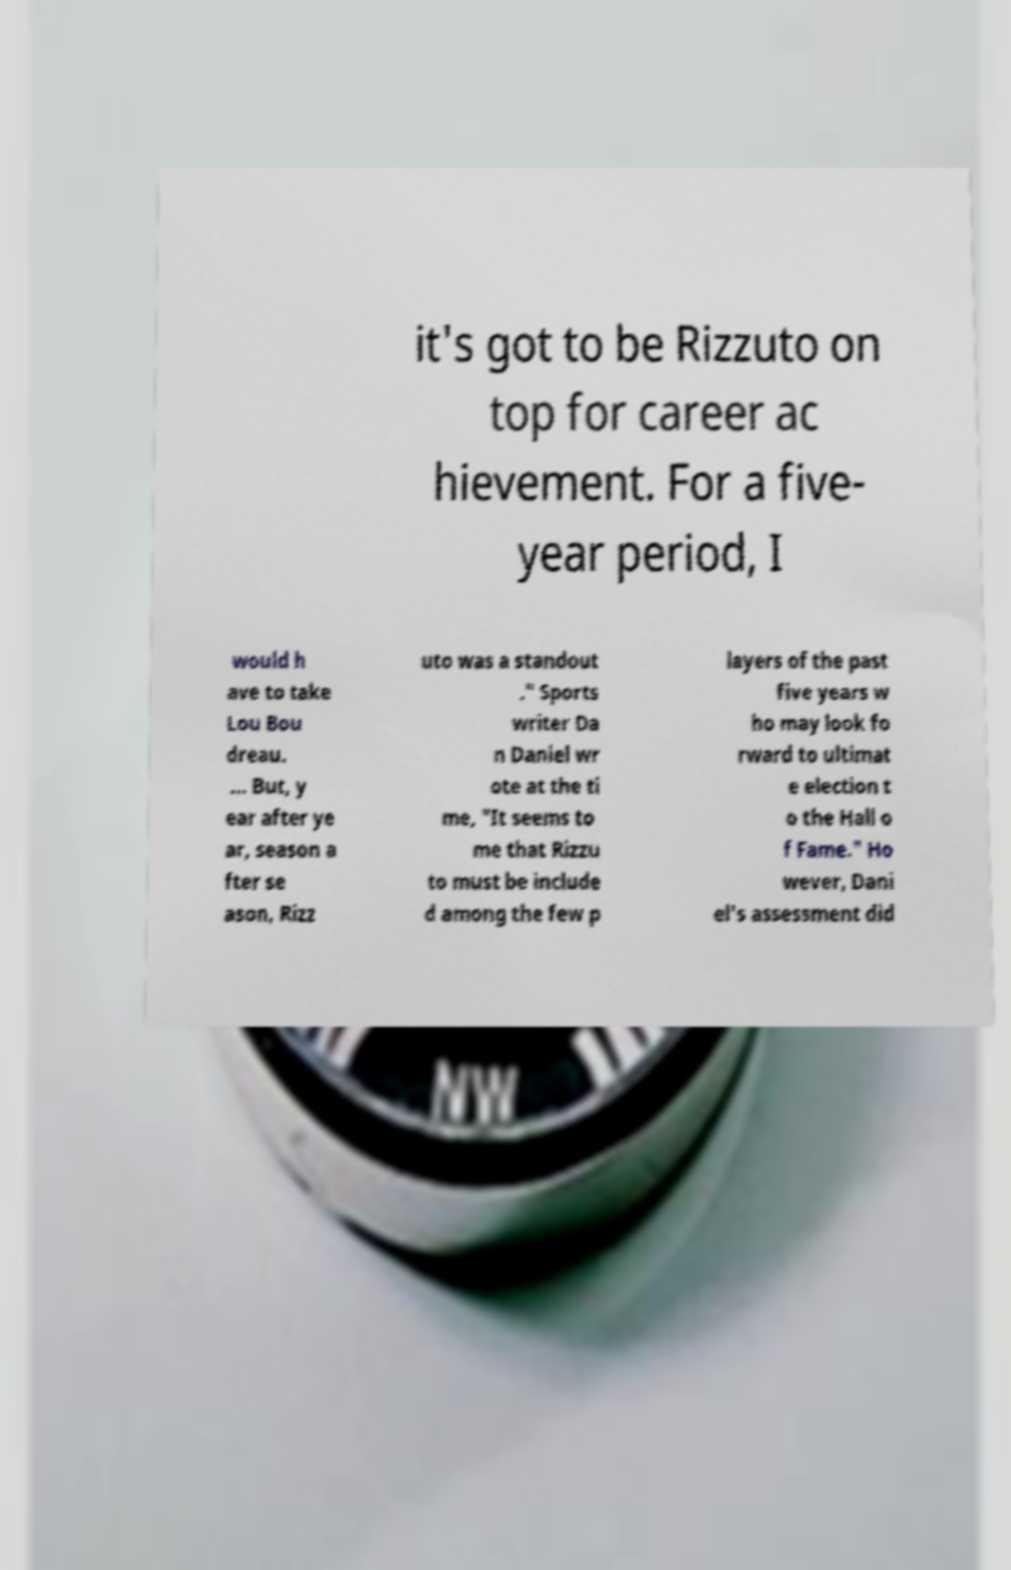Can you accurately transcribe the text from the provided image for me? it's got to be Rizzuto on top for career ac hievement. For a five- year period, I would h ave to take Lou Bou dreau. ... But, y ear after ye ar, season a fter se ason, Rizz uto was a standout ." Sports writer Da n Daniel wr ote at the ti me, "It seems to me that Rizzu to must be include d among the few p layers of the past five years w ho may look fo rward to ultimat e election t o the Hall o f Fame." Ho wever, Dani el's assessment did 